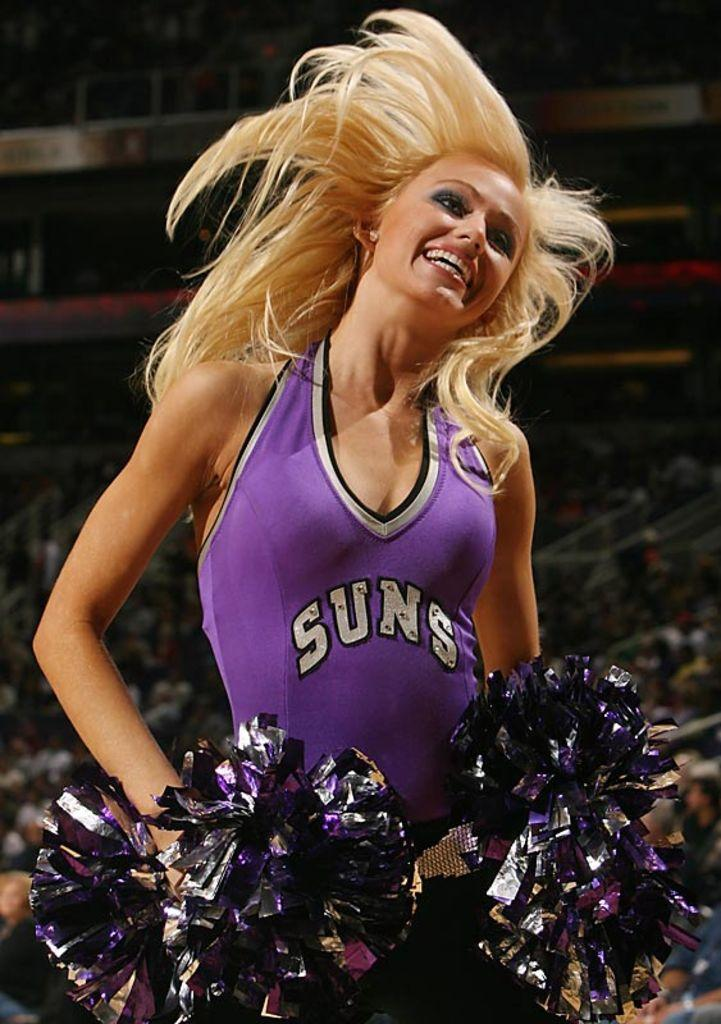<image>
Relay a brief, clear account of the picture shown. A blond cheerleader for the Suns dances and shakes her pom poms. 